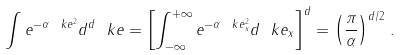Convert formula to latex. <formula><loc_0><loc_0><loc_500><loc_500>\int e ^ { - \alpha \ k e ^ { 2 } } d ^ { d } \ k e = \left [ \int _ { - \infty } ^ { + \infty } e ^ { - \alpha \ k e _ { x } ^ { 2 } } d \ k e _ { x } \right ] ^ { d } = \left ( \frac { \pi } { \alpha } \right ) ^ { d / 2 } \, .</formula> 